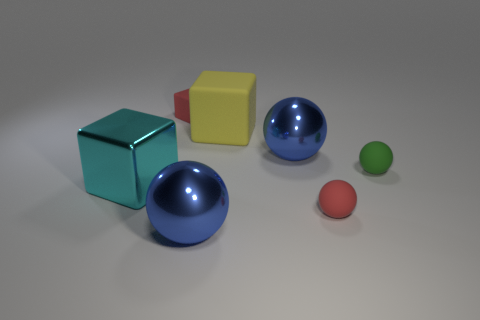Is the material of the small cube the same as the big cyan cube?
Your answer should be compact. No. Are there any green balls that are to the right of the big yellow object that is to the right of the tiny matte cube?
Your answer should be compact. Yes. How many balls are in front of the small green rubber object and to the left of the red matte sphere?
Provide a short and direct response. 1. The big thing that is in front of the red matte sphere has what shape?
Give a very brief answer. Sphere. How many cyan shiny things have the same size as the yellow block?
Provide a short and direct response. 1. Is the color of the tiny ball that is in front of the large cyan thing the same as the tiny matte cube?
Your answer should be compact. Yes. What material is the sphere that is both on the right side of the yellow matte thing and in front of the cyan metal thing?
Your answer should be very brief. Rubber. Is the number of large yellow matte blocks greater than the number of rubber objects?
Your answer should be compact. No. There is a tiny rubber sphere in front of the large object that is left of the object behind the large matte object; what is its color?
Your response must be concise. Red. Is the object that is in front of the red matte sphere made of the same material as the small red cube?
Your response must be concise. No. 